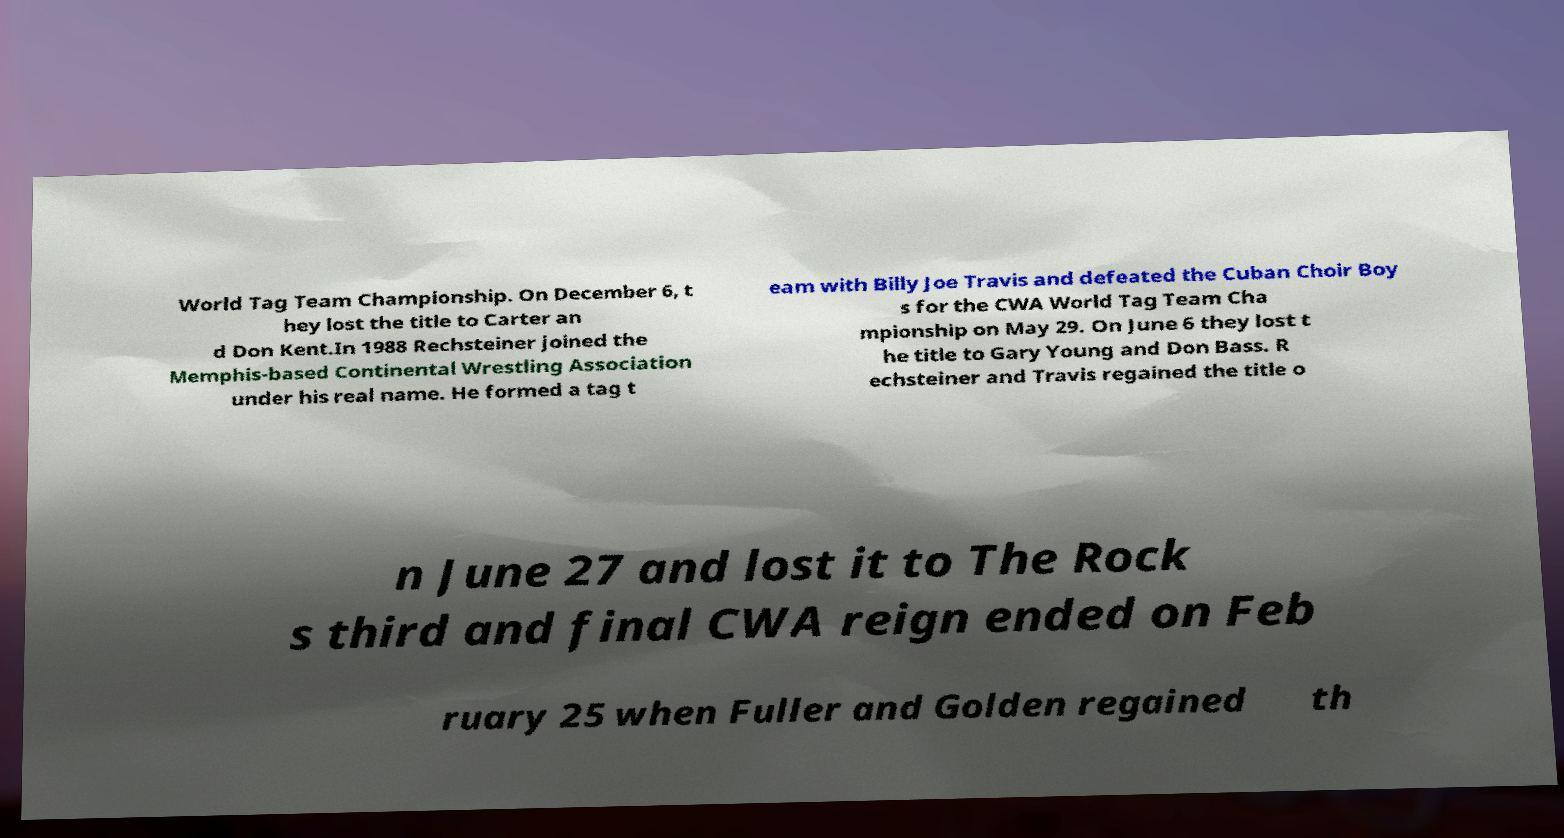I need the written content from this picture converted into text. Can you do that? World Tag Team Championship. On December 6, t hey lost the title to Carter an d Don Kent.In 1988 Rechsteiner joined the Memphis-based Continental Wrestling Association under his real name. He formed a tag t eam with Billy Joe Travis and defeated the Cuban Choir Boy s for the CWA World Tag Team Cha mpionship on May 29. On June 6 they lost t he title to Gary Young and Don Bass. R echsteiner and Travis regained the title o n June 27 and lost it to The Rock s third and final CWA reign ended on Feb ruary 25 when Fuller and Golden regained th 